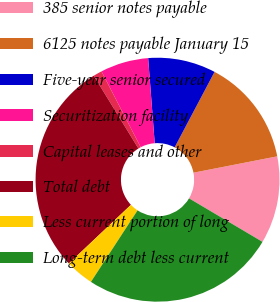<chart> <loc_0><loc_0><loc_500><loc_500><pie_chart><fcel>385 senior notes payable<fcel>6125 notes payable January 15<fcel>Five-year senior secured<fcel>Securitization facility<fcel>Capital leases and other<fcel>Total debt<fcel>Less current portion of long<fcel>Long-term debt less current<nl><fcel>11.58%<fcel>14.19%<fcel>8.97%<fcel>6.37%<fcel>1.16%<fcel>28.29%<fcel>3.76%<fcel>25.68%<nl></chart> 